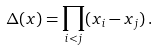Convert formula to latex. <formula><loc_0><loc_0><loc_500><loc_500>\Delta ( x ) = \prod _ { i < j } ( x _ { i } - x _ { j } ) \, .</formula> 